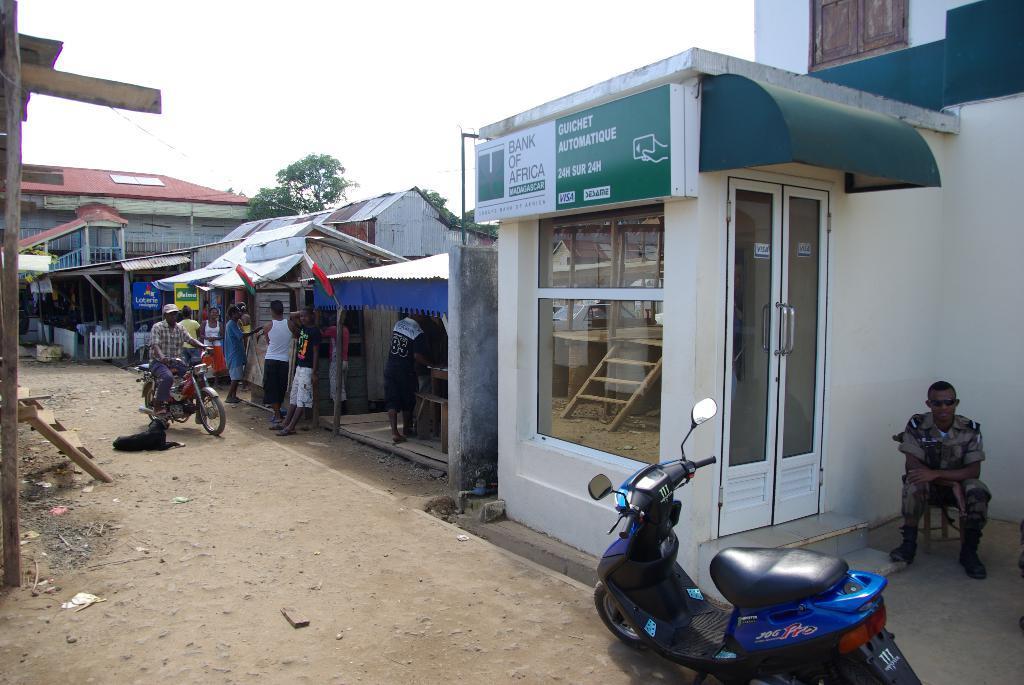Describe this image in one or two sentences. In this image there are a few buildings and stalls, in front of them there are a few people standing, one of them is riding a bike, there is another vehicle parked and there is a person sitting on the stool. In the background there are trees and the sky. 